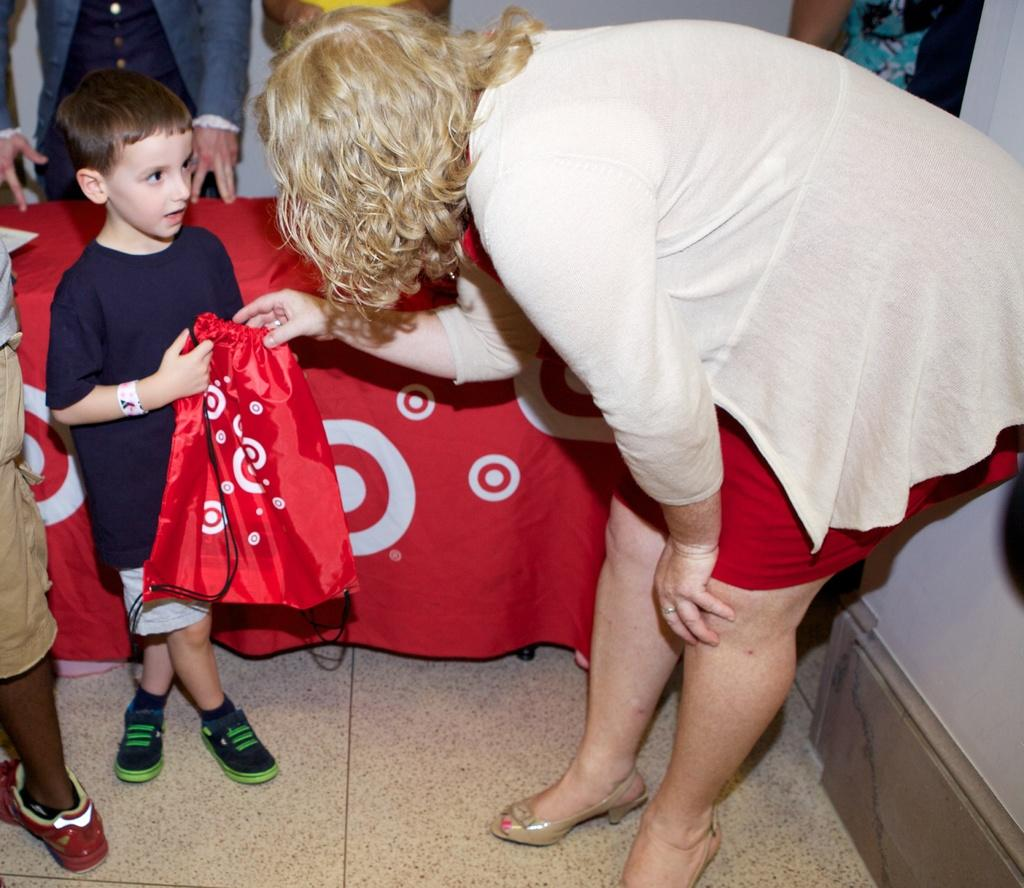How many people are in the image? There are persons in the image. What is located in the middle of the image? There is a table in the middle of the image. What color is the cloth on the table? A red color cloth is present on the table. What is the gender of the persons in the image? There are women in the image. Is there a child in the image? Yes, there is a kid in the image. What is the kid holding? The kid is holding a red color bag. What type of kite is being flown by the women in the image? There is no kite present in the image; the women are not flying any kites. Is there a kettle visible on the table in the image? No, there is no kettle present on the table in the image. 